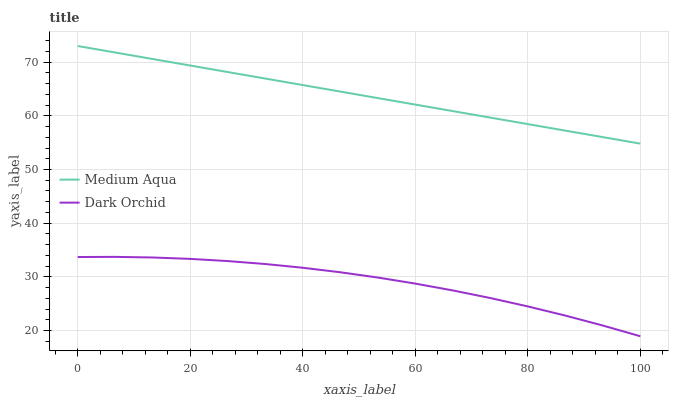Does Dark Orchid have the minimum area under the curve?
Answer yes or no. Yes. Does Medium Aqua have the maximum area under the curve?
Answer yes or no. Yes. Does Dark Orchid have the maximum area under the curve?
Answer yes or no. No. Is Medium Aqua the smoothest?
Answer yes or no. Yes. Is Dark Orchid the roughest?
Answer yes or no. Yes. Is Dark Orchid the smoothest?
Answer yes or no. No. Does Dark Orchid have the lowest value?
Answer yes or no. Yes. Does Medium Aqua have the highest value?
Answer yes or no. Yes. Does Dark Orchid have the highest value?
Answer yes or no. No. Is Dark Orchid less than Medium Aqua?
Answer yes or no. Yes. Is Medium Aqua greater than Dark Orchid?
Answer yes or no. Yes. Does Dark Orchid intersect Medium Aqua?
Answer yes or no. No. 